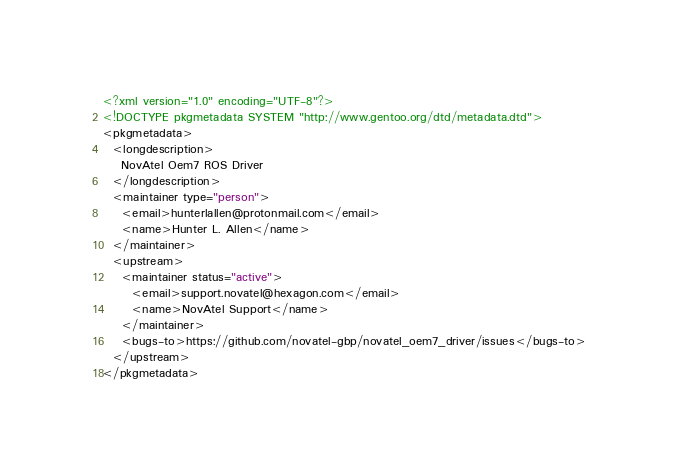<code> <loc_0><loc_0><loc_500><loc_500><_XML_><?xml version="1.0" encoding="UTF-8"?>
<!DOCTYPE pkgmetadata SYSTEM "http://www.gentoo.org/dtd/metadata.dtd">
<pkgmetadata>
  <longdescription>
    NovAtel Oem7 ROS Driver
  </longdescription>
  <maintainer type="person">
    <email>hunterlallen@protonmail.com</email>
    <name>Hunter L. Allen</name>
  </maintainer>
  <upstream>
    <maintainer status="active">
      <email>support.novatel@hexagon.com</email>
      <name>NovAtel Support</name>
    </maintainer>
    <bugs-to>https://github.com/novatel-gbp/novatel_oem7_driver/issues</bugs-to>
  </upstream>
</pkgmetadata>
</code> 